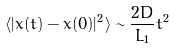<formula> <loc_0><loc_0><loc_500><loc_500>\langle | x ( t ) - x ( 0 ) | ^ { 2 } \rangle \sim \frac { 2 D } { L _ { 1 } } t ^ { 2 }</formula> 